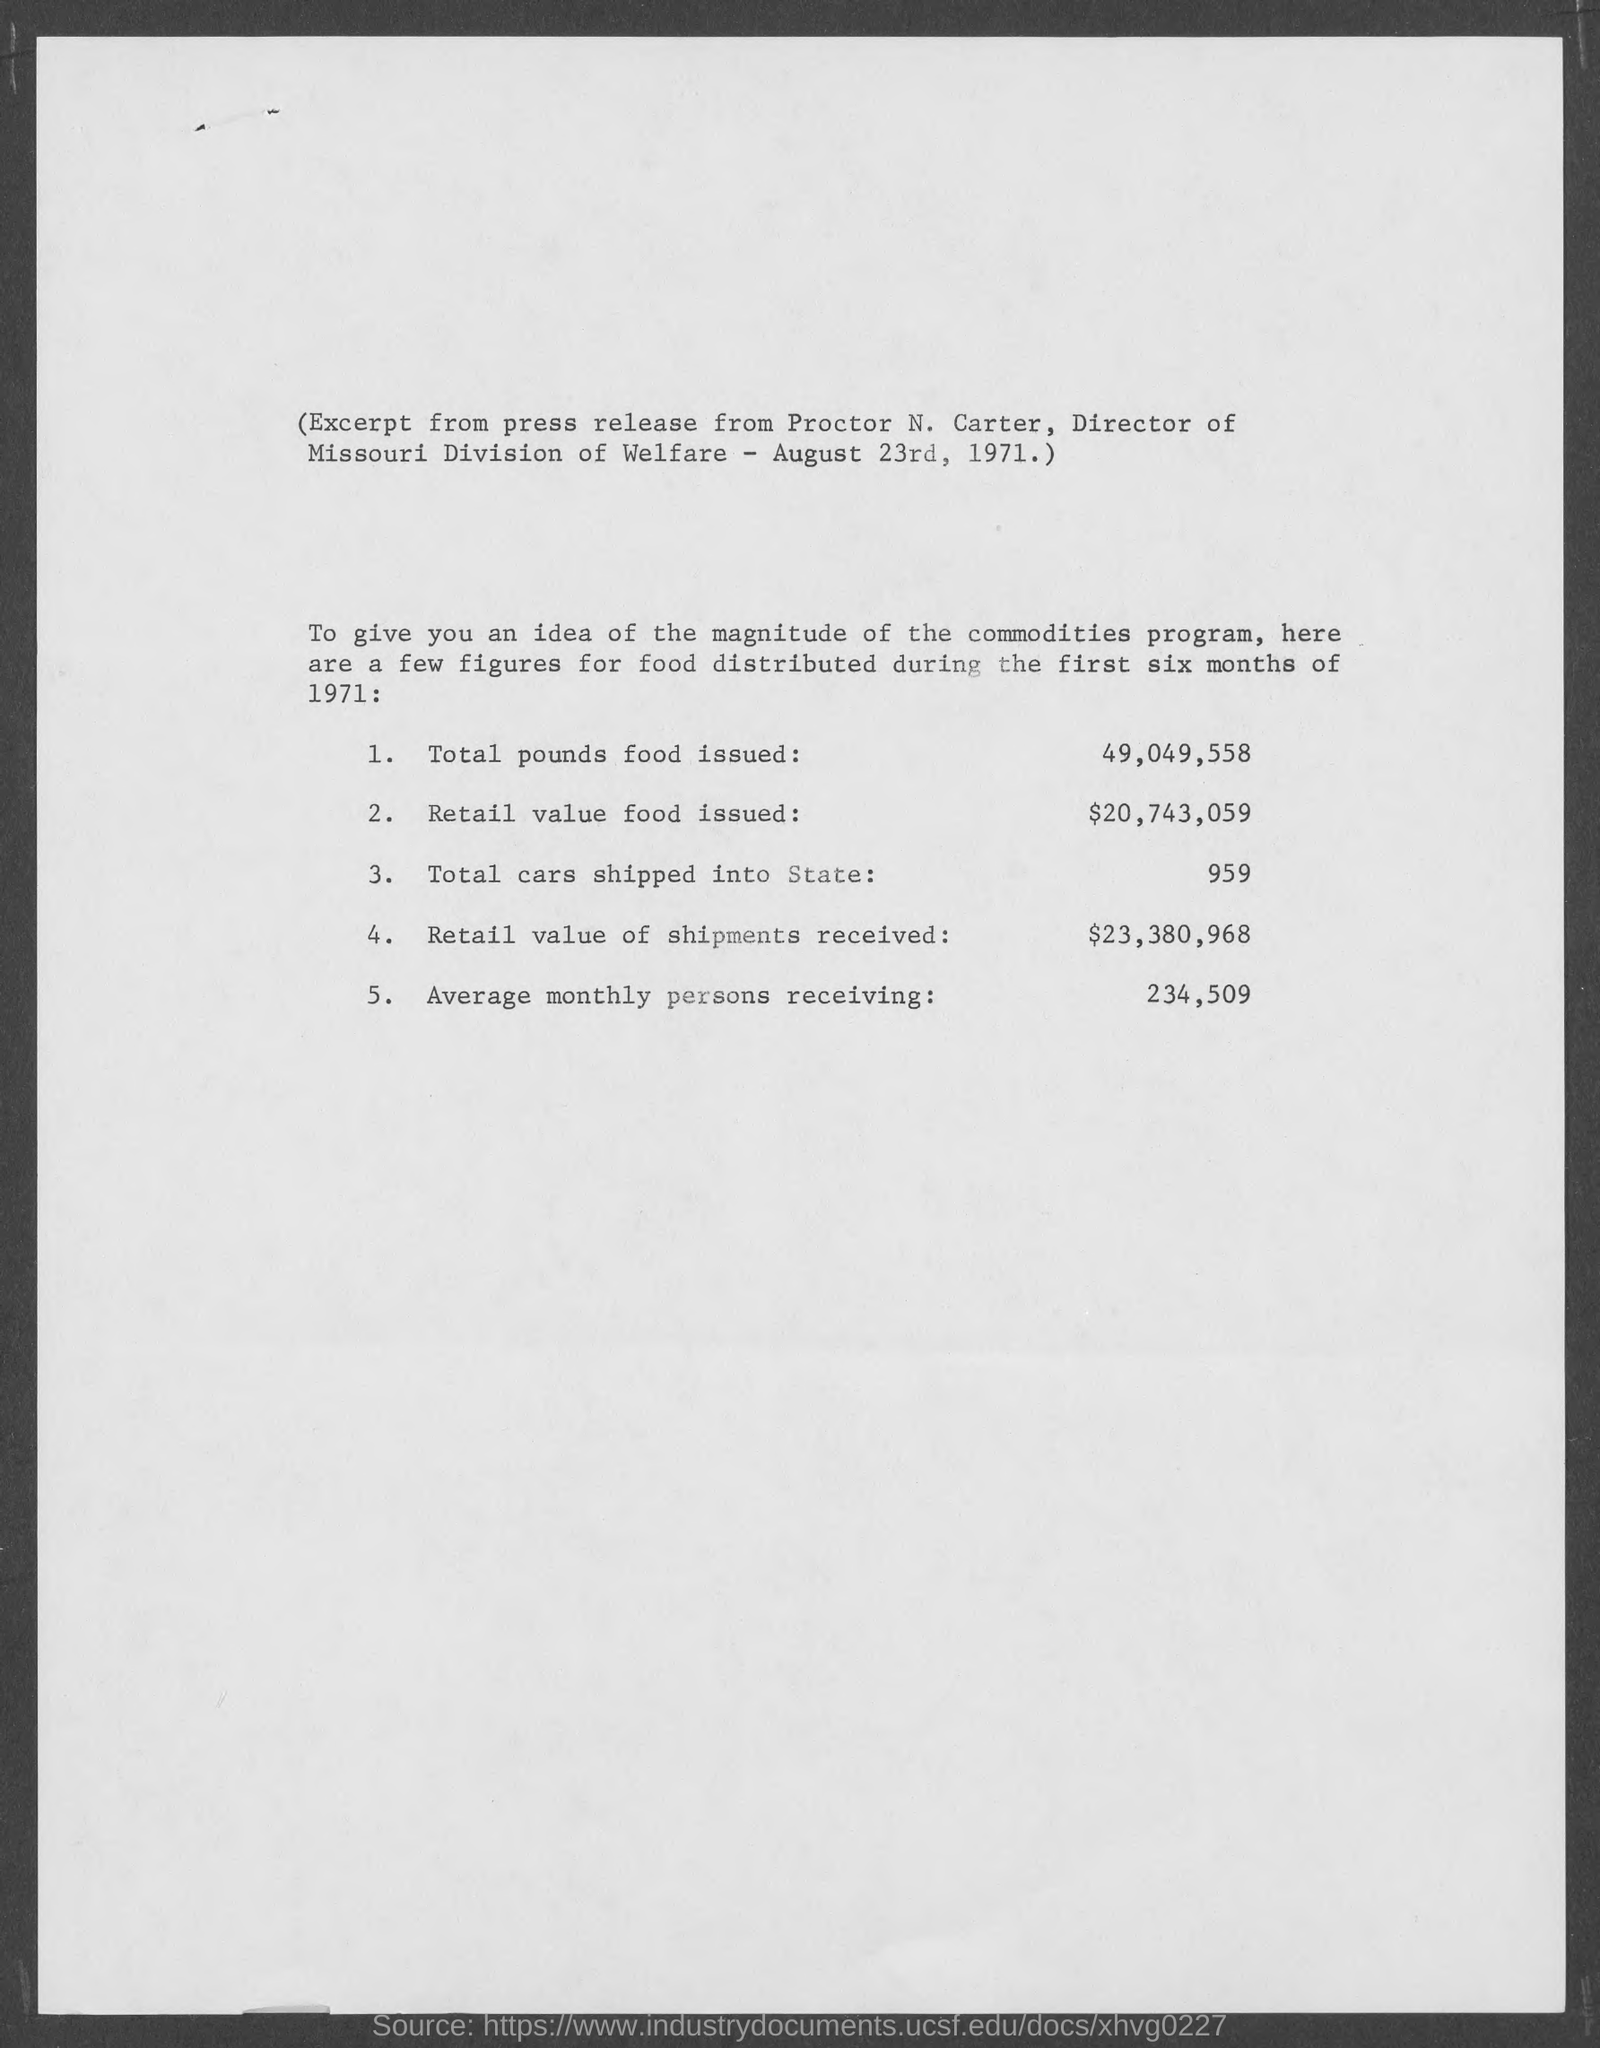Identify some key points in this picture. The total pounds of food issued is 49,049,558... In total, 959 cars were shipped into the state. The total retail value of shipments received was approximately $23,380,968. The average monthly number of individuals receiving support is 234,509. Retail value food issued during the year was $20,743,059. 